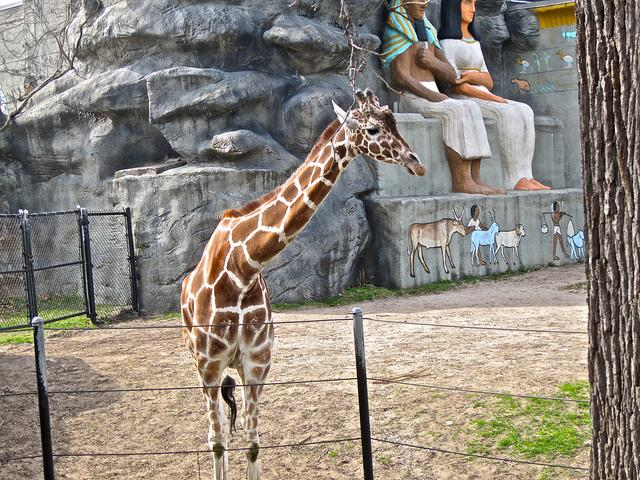Why are the fences lower than the giraffe's neck? Please explain your reasoning. avoid entanglement. Option a chosen for the display shown. 